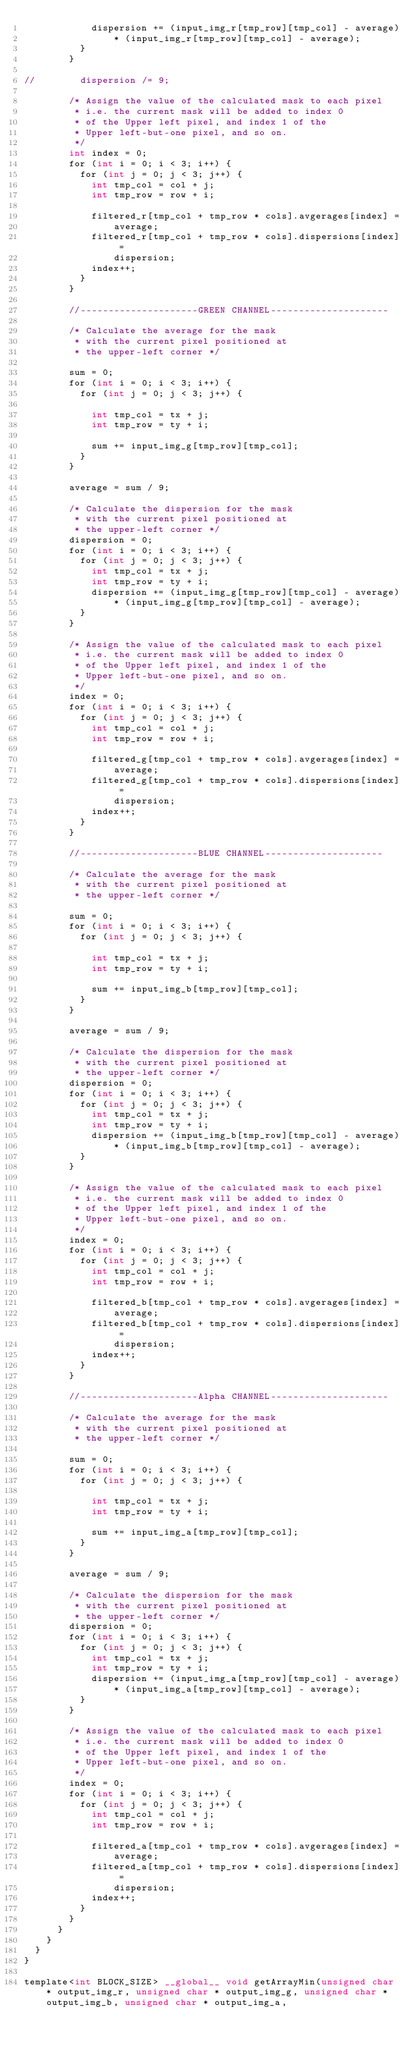<code> <loc_0><loc_0><loc_500><loc_500><_Cuda_>						dispersion += (input_img_r[tmp_row][tmp_col] - average)
								* (input_img_r[tmp_row][tmp_col] - average);
					}
				}

//				dispersion /= 9;

				/* Assign the value of the calculated mask to each pixel
				 * i.e. the current mask will be added to index 0
				 * of the Upper left pixel, and index 1 of the
				 * Upper left-but-one pixel, and so on.
				 */
				int index = 0;
				for (int i = 0; i < 3; i++) {
					for (int j = 0; j < 3; j++) {
						int tmp_col = col + j;
						int tmp_row = row + i;

						filtered_r[tmp_col + tmp_row * cols].avgerages[index] =
								average;
						filtered_r[tmp_col + tmp_row * cols].dispersions[index] =
								dispersion;
						index++;
					}
				}

				//---------------------GREEN CHANNEL---------------------

				/* Calculate the average for the mask
				 * with the current pixel positioned at
				 * the upper-left corner */

				sum = 0;
				for (int i = 0; i < 3; i++) {
					for (int j = 0; j < 3; j++) {

						int tmp_col = tx + j;
						int tmp_row = ty + i;

						sum += input_img_g[tmp_row][tmp_col];
					}
				}

				average = sum / 9;

				/* Calculate the dispersion for the mask
				 * with the current pixel positioned at
				 * the upper-left corner */
				dispersion = 0;
				for (int i = 0; i < 3; i++) {
					for (int j = 0; j < 3; j++) {
						int tmp_col = tx + j;
						int tmp_row = ty + i;
						dispersion += (input_img_g[tmp_row][tmp_col] - average)
								* (input_img_g[tmp_row][tmp_col] - average);
					}
				}

				/* Assign the value of the calculated mask to each pixel
				 * i.e. the current mask will be added to index 0
				 * of the Upper left pixel, and index 1 of the
				 * Upper left-but-one pixel, and so on.
				 */
				index = 0;
				for (int i = 0; i < 3; i++) {
					for (int j = 0; j < 3; j++) {
						int tmp_col = col + j;
						int tmp_row = row + i;

						filtered_g[tmp_col + tmp_row * cols].avgerages[index] =
								average;
						filtered_g[tmp_col + tmp_row * cols].dispersions[index] =
								dispersion;
						index++;
					}
				}

				//---------------------BLUE CHANNEL---------------------

				/* Calculate the average for the mask
				 * with the current pixel positioned at
				 * the upper-left corner */

				sum = 0;
				for (int i = 0; i < 3; i++) {
					for (int j = 0; j < 3; j++) {

						int tmp_col = tx + j;
						int tmp_row = ty + i;

						sum += input_img_b[tmp_row][tmp_col];
					}
				}

				average = sum / 9;

				/* Calculate the dispersion for the mask
				 * with the current pixel positioned at
				 * the upper-left corner */
				dispersion = 0;
				for (int i = 0; i < 3; i++) {
					for (int j = 0; j < 3; j++) {
						int tmp_col = tx + j;
						int tmp_row = ty + i;
						dispersion += (input_img_b[tmp_row][tmp_col] - average)
								* (input_img_b[tmp_row][tmp_col] - average);
					}
				}

				/* Assign the value of the calculated mask to each pixel
				 * i.e. the current mask will be added to index 0
				 * of the Upper left pixel, and index 1 of the
				 * Upper left-but-one pixel, and so on.
				 */
				index = 0;
				for (int i = 0; i < 3; i++) {
					for (int j = 0; j < 3; j++) {
						int tmp_col = col + j;
						int tmp_row = row + i;

						filtered_b[tmp_col + tmp_row * cols].avgerages[index] =
								average;
						filtered_b[tmp_col + tmp_row * cols].dispersions[index] =
								dispersion;
						index++;
					}
				}

				//---------------------Alpha CHANNEL---------------------

				/* Calculate the average for the mask
				 * with the current pixel positioned at
				 * the upper-left corner */

				sum = 0;
				for (int i = 0; i < 3; i++) {
					for (int j = 0; j < 3; j++) {

						int tmp_col = tx + j;
						int tmp_row = ty + i;

						sum += input_img_a[tmp_row][tmp_col];
					}
				}

				average = sum / 9;

				/* Calculate the dispersion for the mask
				 * with the current pixel positioned at
				 * the upper-left corner */
				dispersion = 0;
				for (int i = 0; i < 3; i++) {
					for (int j = 0; j < 3; j++) {
						int tmp_col = tx + j;
						int tmp_row = ty + i;
						dispersion += (input_img_a[tmp_row][tmp_col] - average)
								* (input_img_a[tmp_row][tmp_col] - average);
					}
				}

				/* Assign the value of the calculated mask to each pixel
				 * i.e. the current mask will be added to index 0
				 * of the Upper left pixel, and index 1 of the
				 * Upper left-but-one pixel, and so on.
				 */
				index = 0;
				for (int i = 0; i < 3; i++) {
					for (int j = 0; j < 3; j++) {
						int tmp_col = col + j;
						int tmp_row = row + i;

						filtered_a[tmp_col + tmp_row * cols].avgerages[index] =
								average;
						filtered_a[tmp_col + tmp_row * cols].dispersions[index] =
								dispersion;
						index++;
					}
				}
			}
		}
	}
}

template<int BLOCK_SIZE> __global__ void getArrayMin(unsigned char * output_img_r, unsigned char * output_img_g, unsigned char * output_img_b, unsigned char * output_img_a,</code> 